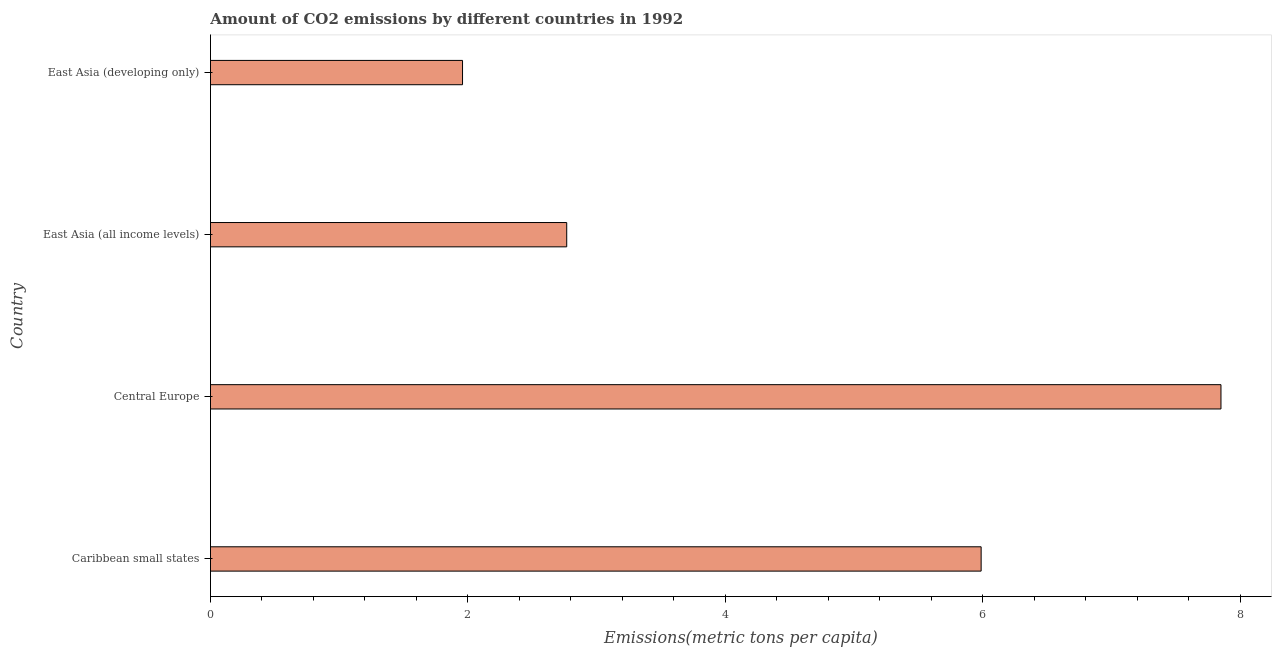Does the graph contain any zero values?
Offer a very short reply. No. What is the title of the graph?
Offer a terse response. Amount of CO2 emissions by different countries in 1992. What is the label or title of the X-axis?
Keep it short and to the point. Emissions(metric tons per capita). What is the label or title of the Y-axis?
Provide a succinct answer. Country. What is the amount of co2 emissions in East Asia (developing only)?
Make the answer very short. 1.96. Across all countries, what is the maximum amount of co2 emissions?
Make the answer very short. 7.85. Across all countries, what is the minimum amount of co2 emissions?
Your answer should be compact. 1.96. In which country was the amount of co2 emissions maximum?
Give a very brief answer. Central Europe. In which country was the amount of co2 emissions minimum?
Provide a succinct answer. East Asia (developing only). What is the sum of the amount of co2 emissions?
Ensure brevity in your answer.  18.56. What is the difference between the amount of co2 emissions in Caribbean small states and East Asia (all income levels)?
Offer a very short reply. 3.22. What is the average amount of co2 emissions per country?
Provide a succinct answer. 4.64. What is the median amount of co2 emissions?
Offer a terse response. 4.38. What is the ratio of the amount of co2 emissions in Central Europe to that in East Asia (developing only)?
Your answer should be compact. 4.01. What is the difference between the highest and the second highest amount of co2 emissions?
Offer a terse response. 1.86. What is the difference between the highest and the lowest amount of co2 emissions?
Make the answer very short. 5.89. Are all the bars in the graph horizontal?
Give a very brief answer. Yes. What is the difference between two consecutive major ticks on the X-axis?
Your answer should be very brief. 2. Are the values on the major ticks of X-axis written in scientific E-notation?
Your answer should be compact. No. What is the Emissions(metric tons per capita) of Caribbean small states?
Make the answer very short. 5.99. What is the Emissions(metric tons per capita) in Central Europe?
Your answer should be very brief. 7.85. What is the Emissions(metric tons per capita) in East Asia (all income levels)?
Provide a short and direct response. 2.77. What is the Emissions(metric tons per capita) in East Asia (developing only)?
Your answer should be very brief. 1.96. What is the difference between the Emissions(metric tons per capita) in Caribbean small states and Central Europe?
Provide a succinct answer. -1.86. What is the difference between the Emissions(metric tons per capita) in Caribbean small states and East Asia (all income levels)?
Your response must be concise. 3.22. What is the difference between the Emissions(metric tons per capita) in Caribbean small states and East Asia (developing only)?
Provide a succinct answer. 4.03. What is the difference between the Emissions(metric tons per capita) in Central Europe and East Asia (all income levels)?
Give a very brief answer. 5.08. What is the difference between the Emissions(metric tons per capita) in Central Europe and East Asia (developing only)?
Your response must be concise. 5.89. What is the difference between the Emissions(metric tons per capita) in East Asia (all income levels) and East Asia (developing only)?
Your answer should be very brief. 0.81. What is the ratio of the Emissions(metric tons per capita) in Caribbean small states to that in Central Europe?
Provide a short and direct response. 0.76. What is the ratio of the Emissions(metric tons per capita) in Caribbean small states to that in East Asia (all income levels)?
Your answer should be very brief. 2.16. What is the ratio of the Emissions(metric tons per capita) in Caribbean small states to that in East Asia (developing only)?
Ensure brevity in your answer.  3.06. What is the ratio of the Emissions(metric tons per capita) in Central Europe to that in East Asia (all income levels)?
Give a very brief answer. 2.84. What is the ratio of the Emissions(metric tons per capita) in Central Europe to that in East Asia (developing only)?
Your answer should be compact. 4.01. What is the ratio of the Emissions(metric tons per capita) in East Asia (all income levels) to that in East Asia (developing only)?
Provide a short and direct response. 1.41. 